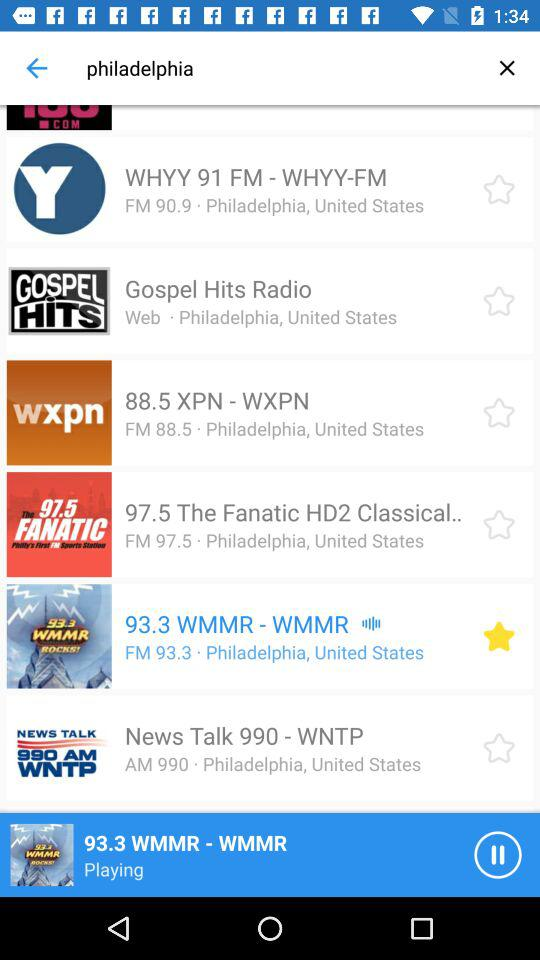What country is mentioned? The mentioned country is the United States. 